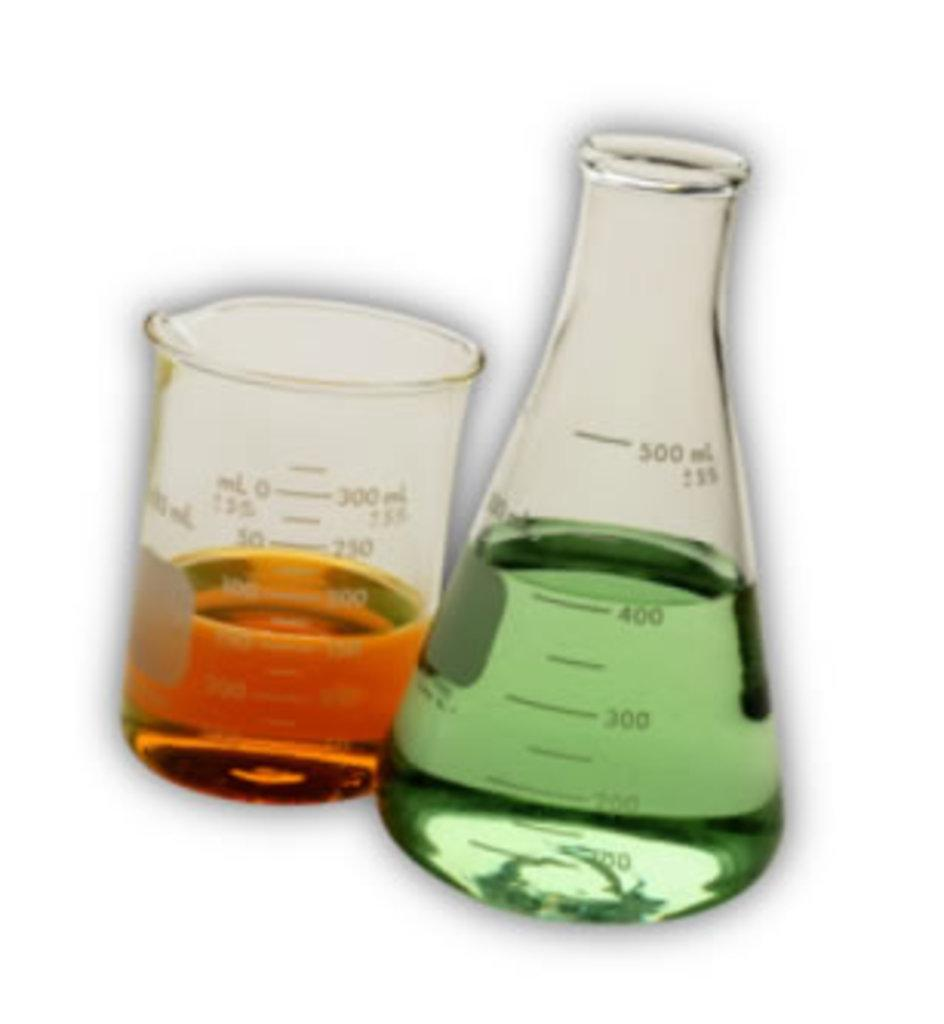<image>
Give a short and clear explanation of the subsequent image. A beaker and flask are next to each other, and the flask has a marking of 500 ml/ 